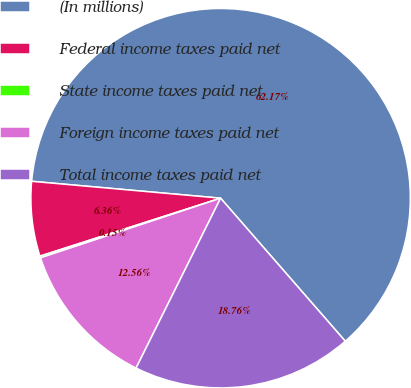<chart> <loc_0><loc_0><loc_500><loc_500><pie_chart><fcel>(In millions)<fcel>Federal income taxes paid net<fcel>State income taxes paid net<fcel>Foreign income taxes paid net<fcel>Total income taxes paid net<nl><fcel>62.17%<fcel>6.36%<fcel>0.15%<fcel>12.56%<fcel>18.76%<nl></chart> 